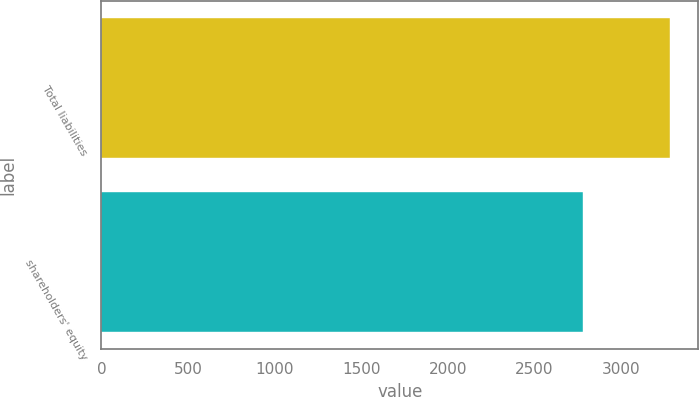Convert chart to OTSL. <chart><loc_0><loc_0><loc_500><loc_500><bar_chart><fcel>Total liabilities<fcel>shareholders' equity<nl><fcel>3280.2<fcel>2778.2<nl></chart> 